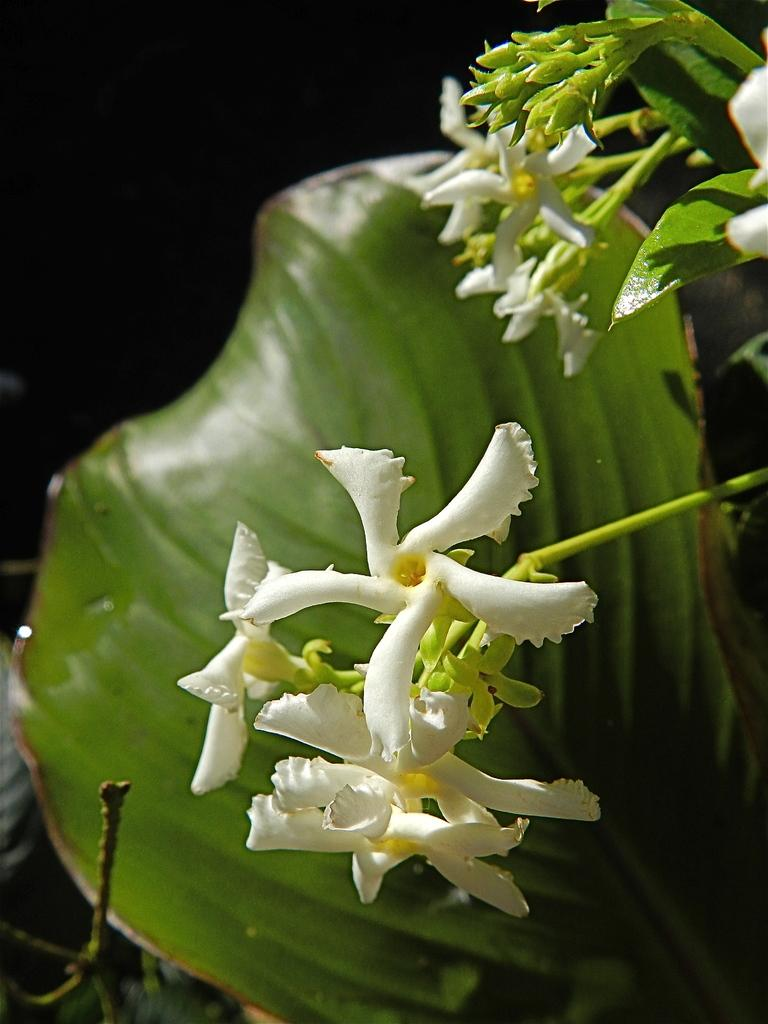What type of plant can be seen in the image? There is a plant with flowers in the image. Can you describe any specific features of the plant? There is a big green leaf in the background of the image. What type of feather can be seen on the minister's hat in the image? There is no minister or hat present in the image; it features a plant with flowers and a big green leaf. 